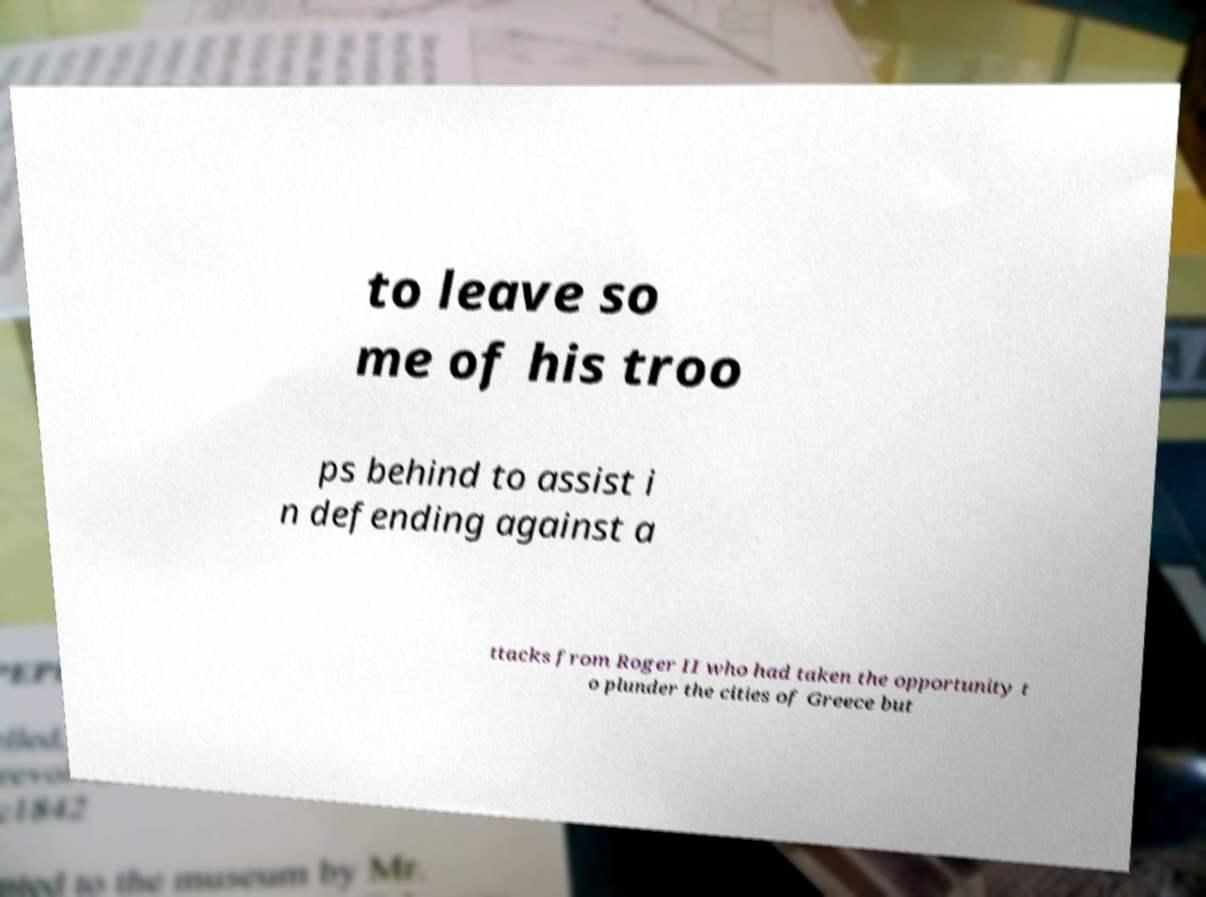Can you read and provide the text displayed in the image?This photo seems to have some interesting text. Can you extract and type it out for me? to leave so me of his troo ps behind to assist i n defending against a ttacks from Roger II who had taken the opportunity t o plunder the cities of Greece but 